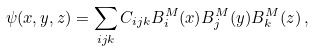Convert formula to latex. <formula><loc_0><loc_0><loc_500><loc_500>\psi ( x , y , z ) = \sum _ { i j k } C _ { i j k } B _ { i } ^ { M } ( x ) B _ { j } ^ { M } ( y ) B _ { k } ^ { M } ( z ) \, ,</formula> 